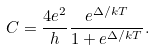Convert formula to latex. <formula><loc_0><loc_0><loc_500><loc_500>C = \frac { 4 e ^ { 2 } } { h } \frac { e ^ { \Delta / k T } } { 1 + e ^ { \Delta / k T } } .</formula> 